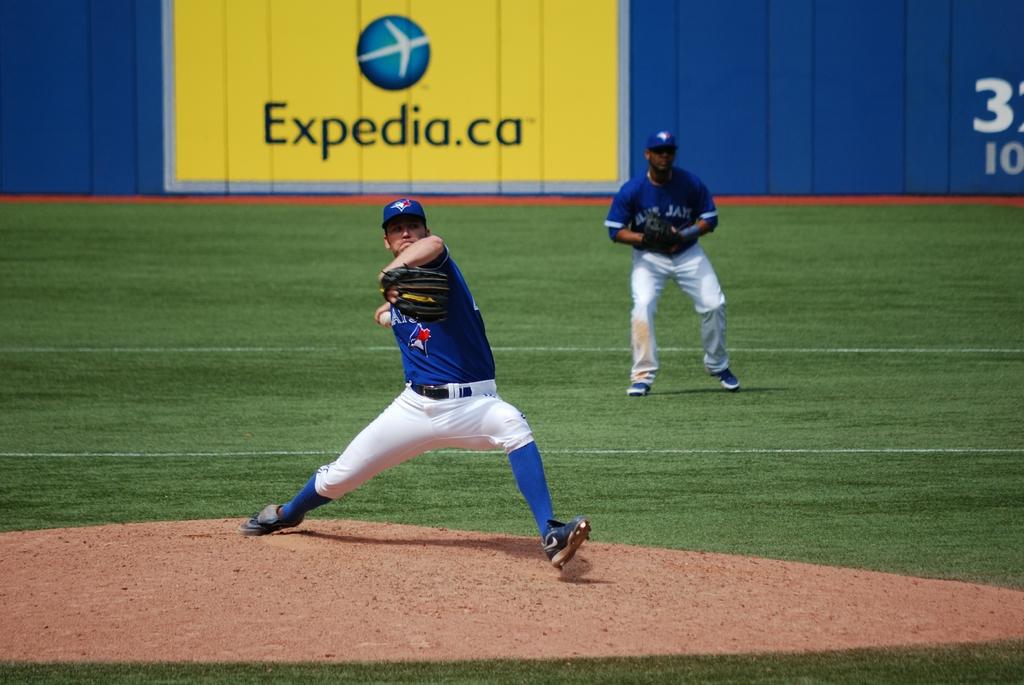What website is advertised at this ball park?
Your answer should be very brief. Expedia.ca. What number is under the 3 in back?
Your answer should be compact. 10. 